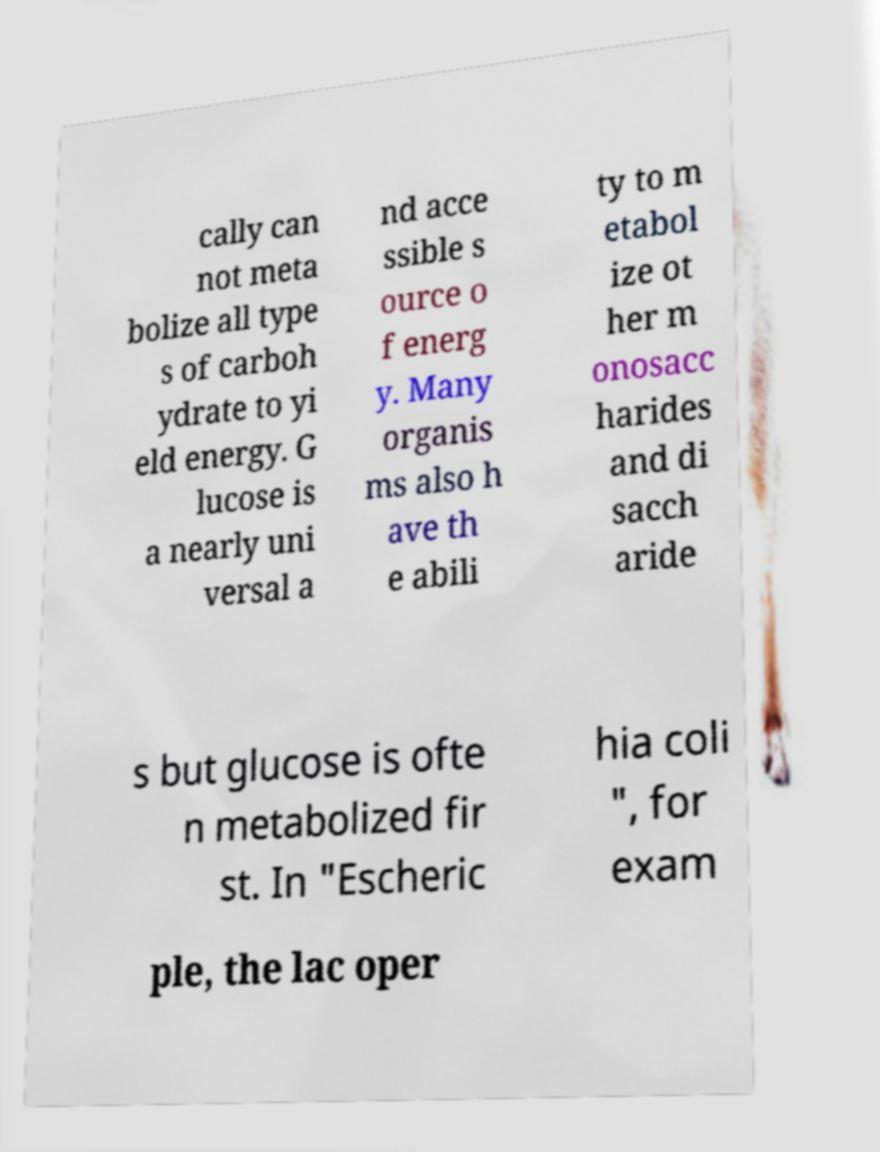Could you assist in decoding the text presented in this image and type it out clearly? cally can not meta bolize all type s of carboh ydrate to yi eld energy. G lucose is a nearly uni versal a nd acce ssible s ource o f energ y. Many organis ms also h ave th e abili ty to m etabol ize ot her m onosacc harides and di sacch aride s but glucose is ofte n metabolized fir st. In "Escheric hia coli ", for exam ple, the lac oper 